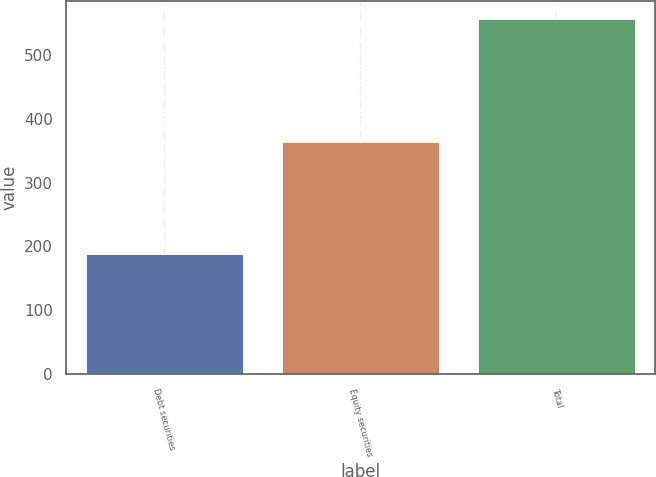Convert chart to OTSL. <chart><loc_0><loc_0><loc_500><loc_500><bar_chart><fcel>Debt securities<fcel>Equity securities<fcel>Total<nl><fcel>189<fcel>364<fcel>556<nl></chart> 